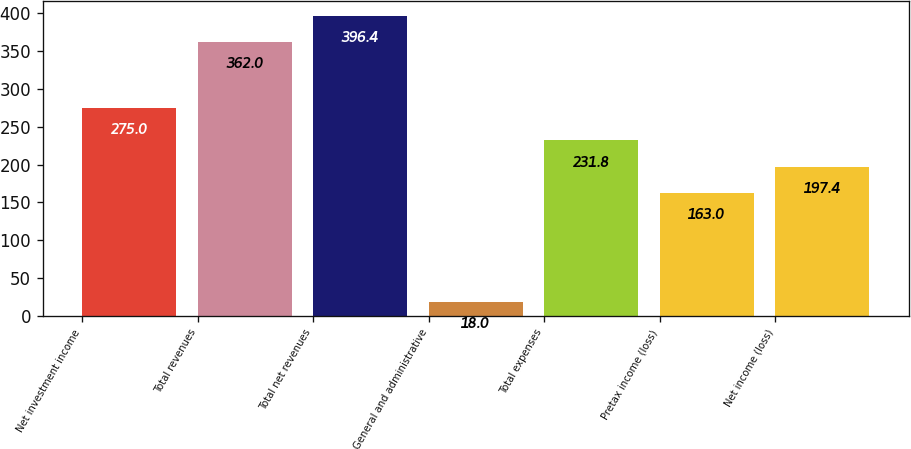Convert chart to OTSL. <chart><loc_0><loc_0><loc_500><loc_500><bar_chart><fcel>Net investment income<fcel>Total revenues<fcel>Total net revenues<fcel>General and administrative<fcel>Total expenses<fcel>Pretax income (loss)<fcel>Net income (loss)<nl><fcel>275<fcel>362<fcel>396.4<fcel>18<fcel>231.8<fcel>163<fcel>197.4<nl></chart> 